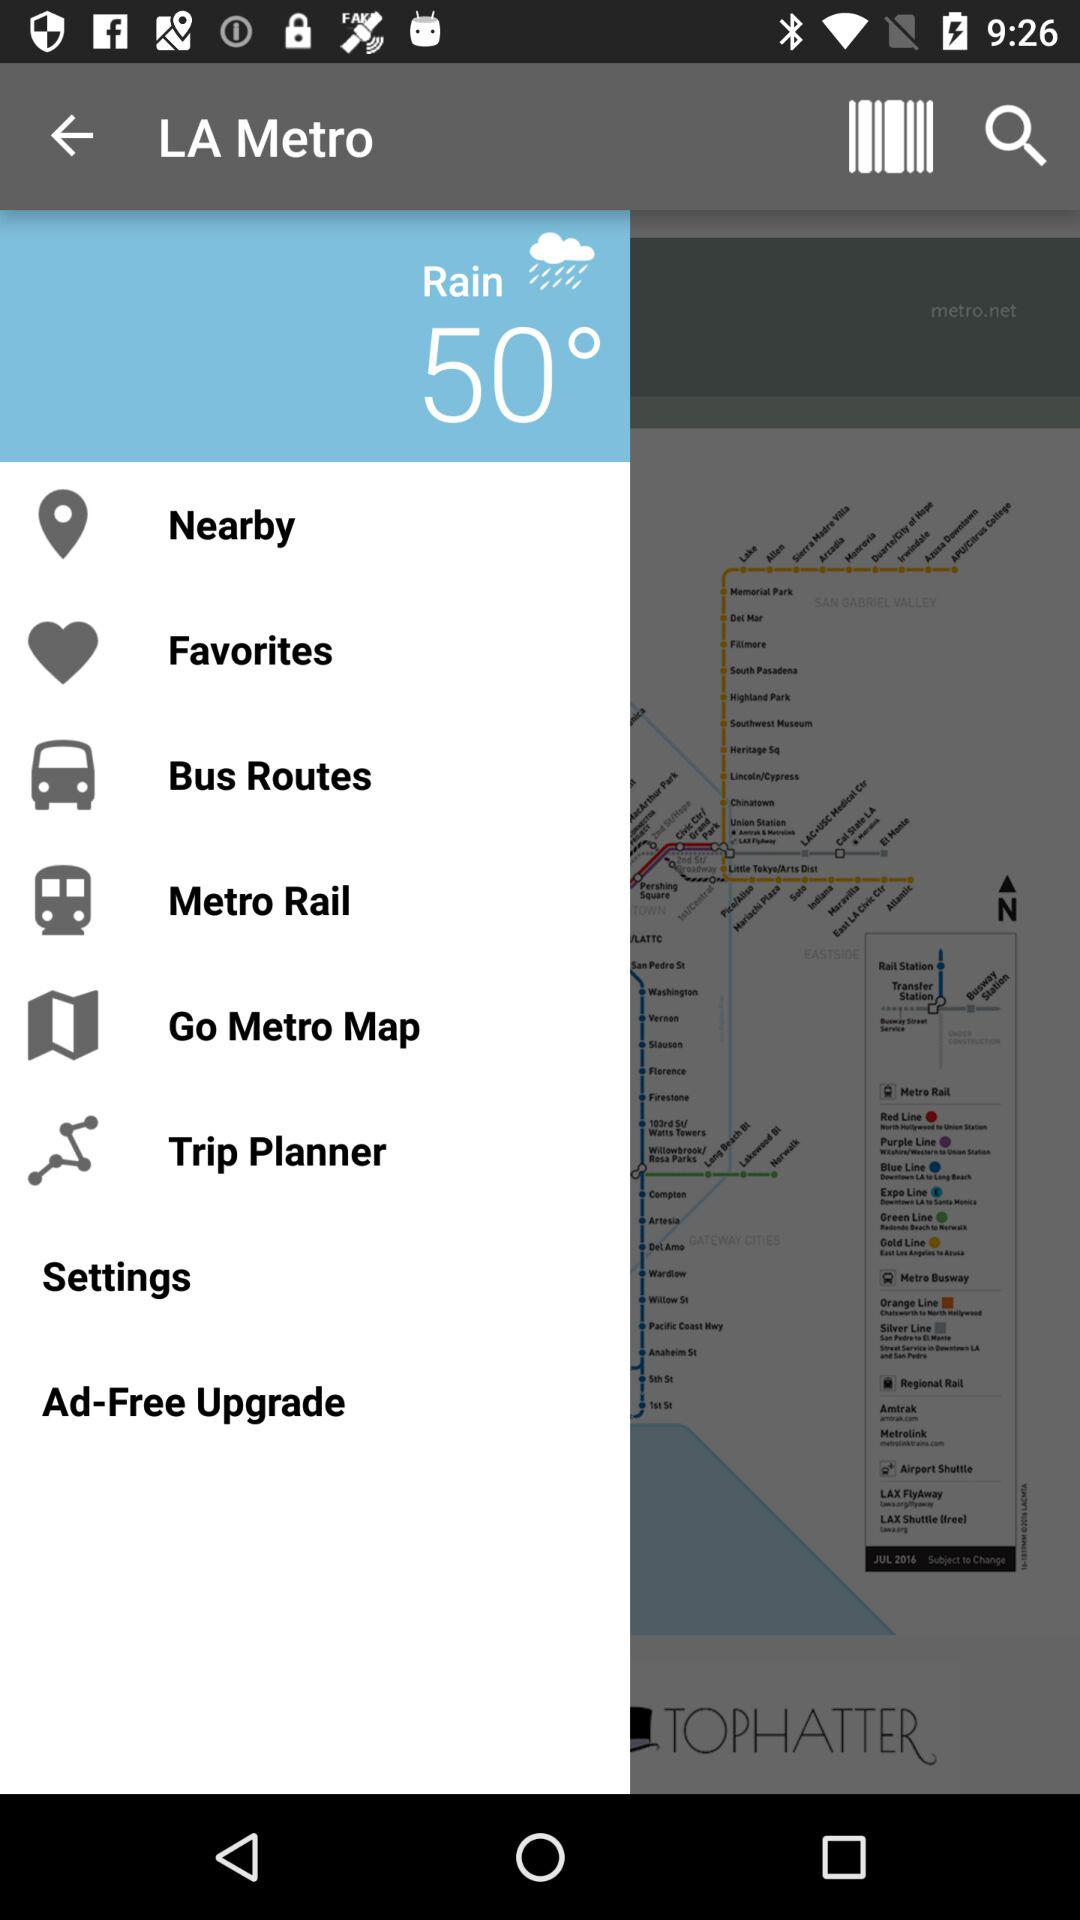Which type of weather is shown? The type of weather shown is rain. 